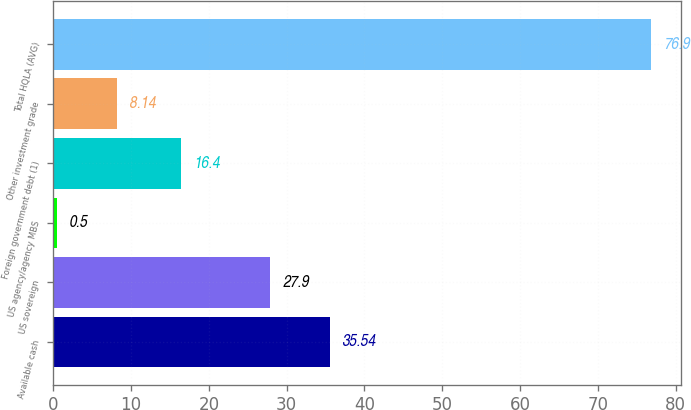<chart> <loc_0><loc_0><loc_500><loc_500><bar_chart><fcel>Available cash<fcel>US sovereign<fcel>US agency/agency MBS<fcel>Foreign government debt (1)<fcel>Other investment grade<fcel>Total HQLA (AVG)<nl><fcel>35.54<fcel>27.9<fcel>0.5<fcel>16.4<fcel>8.14<fcel>76.9<nl></chart> 